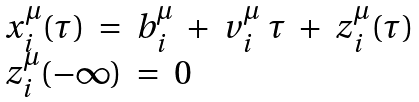Convert formula to latex. <formula><loc_0><loc_0><loc_500><loc_500>\begin{array} { l l l } x ^ { \mu } _ { i } ( \tau ) \ = \ b _ { i } ^ { \mu } \ + \ v _ { i } ^ { \mu } \ \tau \ + \ z _ { i } ^ { \mu } ( \tau ) \\ z _ { i } ^ { \mu } ( - \infty ) \ = \ 0 \end{array}</formula> 